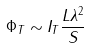Convert formula to latex. <formula><loc_0><loc_0><loc_500><loc_500>\Phi _ { T } \sim I _ { T } \frac { L \lambda ^ { 2 } } { S }</formula> 